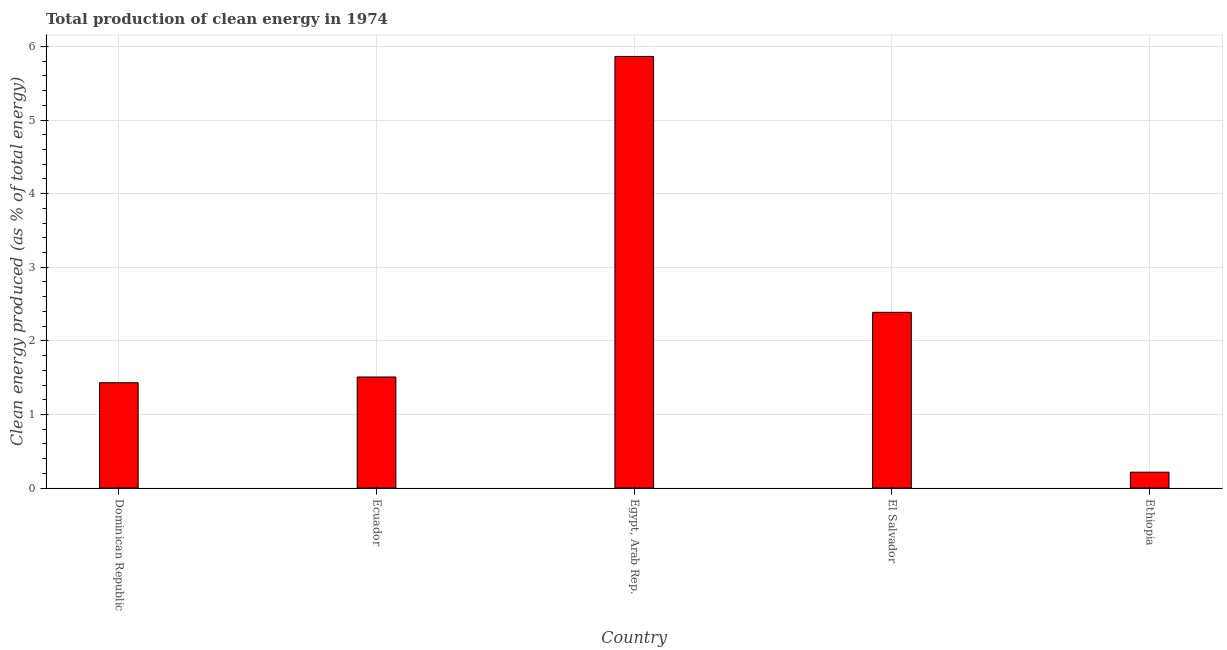What is the title of the graph?
Make the answer very short. Total production of clean energy in 1974. What is the label or title of the Y-axis?
Give a very brief answer. Clean energy produced (as % of total energy). What is the production of clean energy in Dominican Republic?
Provide a succinct answer. 1.43. Across all countries, what is the maximum production of clean energy?
Offer a very short reply. 5.86. Across all countries, what is the minimum production of clean energy?
Offer a terse response. 0.22. In which country was the production of clean energy maximum?
Provide a succinct answer. Egypt, Arab Rep. In which country was the production of clean energy minimum?
Make the answer very short. Ethiopia. What is the sum of the production of clean energy?
Offer a very short reply. 11.41. What is the difference between the production of clean energy in Dominican Republic and Ecuador?
Offer a very short reply. -0.08. What is the average production of clean energy per country?
Give a very brief answer. 2.28. What is the median production of clean energy?
Offer a terse response. 1.51. In how many countries, is the production of clean energy greater than 2.6 %?
Your response must be concise. 1. What is the ratio of the production of clean energy in Dominican Republic to that in El Salvador?
Keep it short and to the point. 0.6. Is the difference between the production of clean energy in Ecuador and Egypt, Arab Rep. greater than the difference between any two countries?
Ensure brevity in your answer.  No. What is the difference between the highest and the second highest production of clean energy?
Give a very brief answer. 3.48. What is the difference between the highest and the lowest production of clean energy?
Keep it short and to the point. 5.65. In how many countries, is the production of clean energy greater than the average production of clean energy taken over all countries?
Your response must be concise. 2. Are all the bars in the graph horizontal?
Offer a terse response. No. Are the values on the major ticks of Y-axis written in scientific E-notation?
Provide a succinct answer. No. What is the Clean energy produced (as % of total energy) in Dominican Republic?
Keep it short and to the point. 1.43. What is the Clean energy produced (as % of total energy) of Ecuador?
Your response must be concise. 1.51. What is the Clean energy produced (as % of total energy) of Egypt, Arab Rep.?
Provide a succinct answer. 5.86. What is the Clean energy produced (as % of total energy) in El Salvador?
Give a very brief answer. 2.39. What is the Clean energy produced (as % of total energy) of Ethiopia?
Provide a short and direct response. 0.22. What is the difference between the Clean energy produced (as % of total energy) in Dominican Republic and Ecuador?
Offer a very short reply. -0.08. What is the difference between the Clean energy produced (as % of total energy) in Dominican Republic and Egypt, Arab Rep.?
Your answer should be compact. -4.43. What is the difference between the Clean energy produced (as % of total energy) in Dominican Republic and El Salvador?
Provide a succinct answer. -0.96. What is the difference between the Clean energy produced (as % of total energy) in Dominican Republic and Ethiopia?
Make the answer very short. 1.22. What is the difference between the Clean energy produced (as % of total energy) in Ecuador and Egypt, Arab Rep.?
Your answer should be very brief. -4.35. What is the difference between the Clean energy produced (as % of total energy) in Ecuador and El Salvador?
Give a very brief answer. -0.88. What is the difference between the Clean energy produced (as % of total energy) in Ecuador and Ethiopia?
Your response must be concise. 1.29. What is the difference between the Clean energy produced (as % of total energy) in Egypt, Arab Rep. and El Salvador?
Make the answer very short. 3.48. What is the difference between the Clean energy produced (as % of total energy) in Egypt, Arab Rep. and Ethiopia?
Ensure brevity in your answer.  5.65. What is the difference between the Clean energy produced (as % of total energy) in El Salvador and Ethiopia?
Offer a terse response. 2.17. What is the ratio of the Clean energy produced (as % of total energy) in Dominican Republic to that in Ecuador?
Ensure brevity in your answer.  0.95. What is the ratio of the Clean energy produced (as % of total energy) in Dominican Republic to that in Egypt, Arab Rep.?
Ensure brevity in your answer.  0.24. What is the ratio of the Clean energy produced (as % of total energy) in Dominican Republic to that in El Salvador?
Your answer should be very brief. 0.6. What is the ratio of the Clean energy produced (as % of total energy) in Dominican Republic to that in Ethiopia?
Provide a short and direct response. 6.62. What is the ratio of the Clean energy produced (as % of total energy) in Ecuador to that in Egypt, Arab Rep.?
Ensure brevity in your answer.  0.26. What is the ratio of the Clean energy produced (as % of total energy) in Ecuador to that in El Salvador?
Make the answer very short. 0.63. What is the ratio of the Clean energy produced (as % of total energy) in Ecuador to that in Ethiopia?
Offer a very short reply. 6.98. What is the ratio of the Clean energy produced (as % of total energy) in Egypt, Arab Rep. to that in El Salvador?
Offer a terse response. 2.46. What is the ratio of the Clean energy produced (as % of total energy) in Egypt, Arab Rep. to that in Ethiopia?
Your answer should be very brief. 27.13. What is the ratio of the Clean energy produced (as % of total energy) in El Salvador to that in Ethiopia?
Your answer should be very brief. 11.05. 